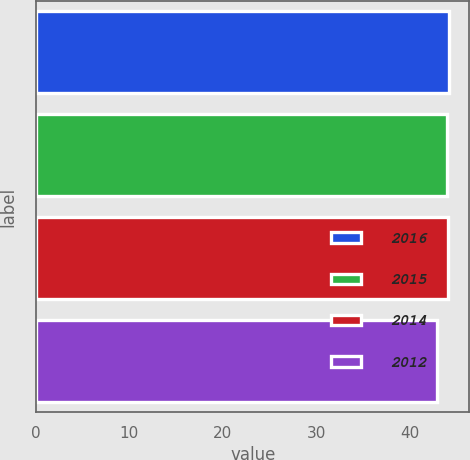<chart> <loc_0><loc_0><loc_500><loc_500><bar_chart><fcel>2016<fcel>2015<fcel>2014<fcel>2012<nl><fcel>44.21<fcel>43.99<fcel>44.1<fcel>42.91<nl></chart> 